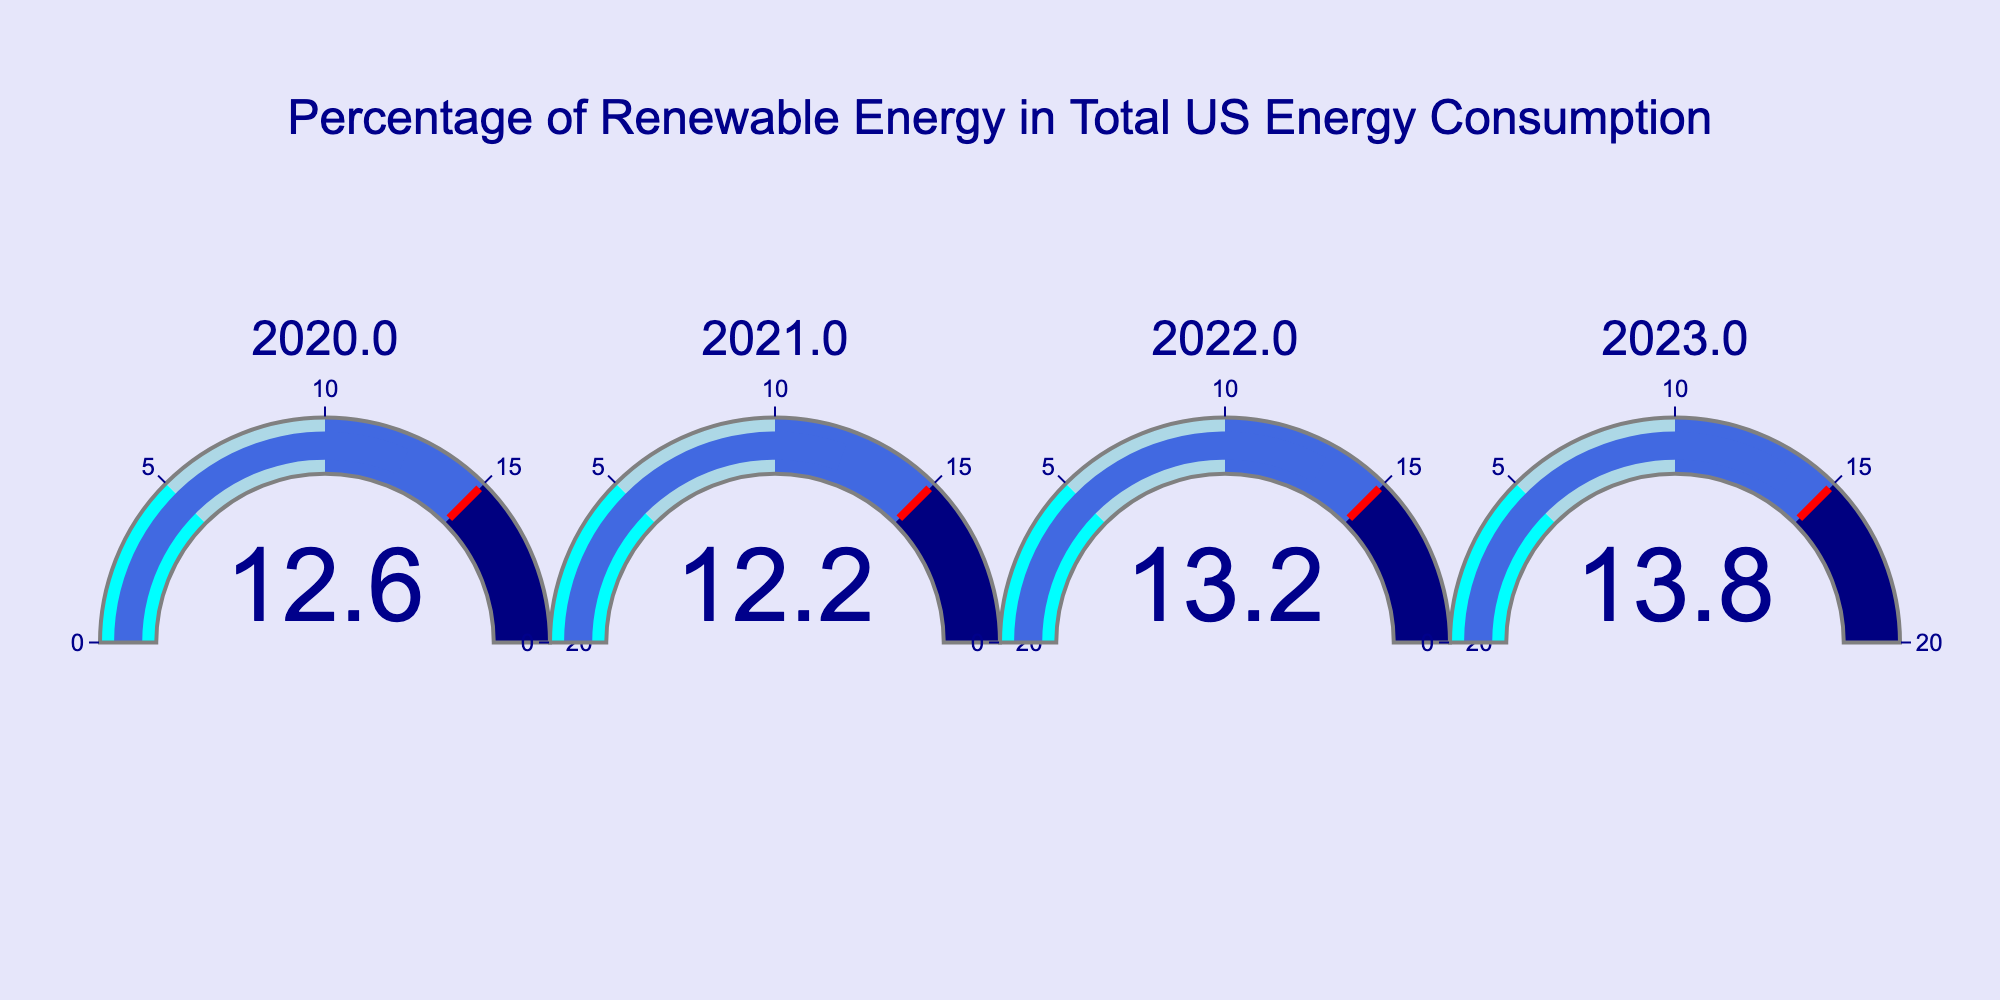Which year had the highest percentage of renewable energy consumption? By looking at the values displayed on each gauge, the highest percentage is 13.8 in the year 2023.
Answer: 2023 What is the title of the figure? The title of the figure is usually located at the top center of the chart and reads "Percentage of Renewable Energy in Total US Energy Consumption".
Answer: Percentage of Renewable Energy in Total US Energy Consumption How does the renewable energy percentage change from 2022 to 2023? The gauge chart shows a value of 13.2 for 2022 and 13.8 for 2023. The change is calculated by subtracting the 2022 value from the 2023 value: 13.8 - 13.2 = 0.6.
Answer: It increases by 0.6 Which year had the lowest percentage of renewable energy consumption? By looking at the values displayed on each gauge, the lowest percentage is 12.2 in the year 2021.
Answer: 2021 How many years of data are presented in the figure? Each gauge displays a different year, and there are four gauges, corresponding to four different years.
Answer: 4 years Is there a year when the renewable energy percentage was below 13%? By looking at the gauges, the years 2020 and 2021 have percentages of 12.6 and 12.2, respectively, both of which are below 13%.
Answer: Yes What color represents the highest interval range on the gauges? Observing the color gradient on the gauges, the highest interval (15-20) is represented by the color navy.
Answer: Navy Was the renewable energy percentage ever below the 10% mark in the data presented? Observing the values on each gauge (12.6, 12.2, 13.2, 13.8), none of them are below 10%.
Answer: No What is the average renewable energy percentage across all the years shown? Add up the percentages: 12.6 + 12.2 + 13.2 + 13.8 = 51.8. Then divide by the number of years (4): 51.8 / 4 = 12.95.
Answer: 12.95 